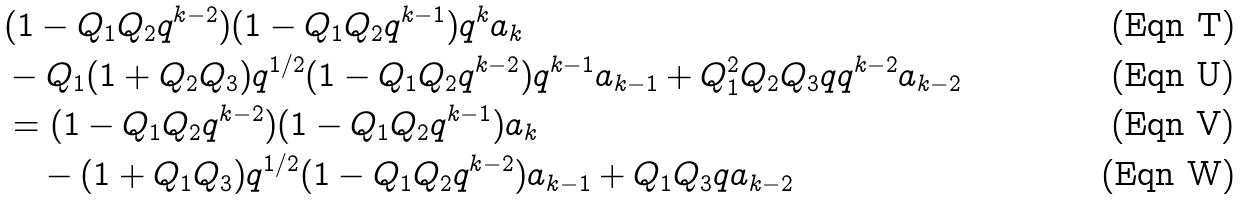Convert formula to latex. <formula><loc_0><loc_0><loc_500><loc_500>& ( 1 - Q _ { 1 } Q _ { 2 } q ^ { k - 2 } ) ( 1 - Q _ { 1 } Q _ { 2 } q ^ { k - 1 } ) q ^ { k } a _ { k } \\ & - Q _ { 1 } ( 1 + Q _ { 2 } Q _ { 3 } ) q ^ { 1 / 2 } ( 1 - Q _ { 1 } Q _ { 2 } q ^ { k - 2 } ) q ^ { k - 1 } a _ { k - 1 } + Q _ { 1 } ^ { 2 } Q _ { 2 } Q _ { 3 } q q ^ { k - 2 } a _ { k - 2 } \\ & = ( 1 - Q _ { 1 } Q _ { 2 } q ^ { k - 2 } ) ( 1 - Q _ { 1 } Q _ { 2 } q ^ { k - 1 } ) a _ { k } \\ & \quad - ( 1 + Q _ { 1 } Q _ { 3 } ) q ^ { 1 / 2 } ( 1 - Q _ { 1 } Q _ { 2 } q ^ { k - 2 } ) a _ { k - 1 } + Q _ { 1 } Q _ { 3 } q a _ { k - 2 }</formula> 